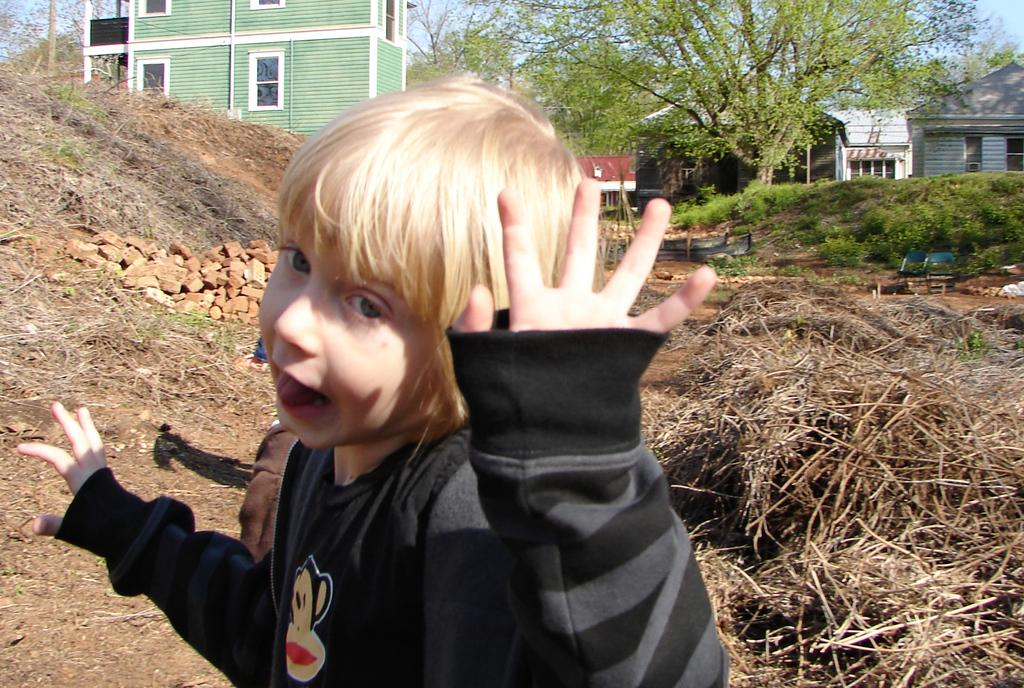What is the main subject of the image? There is a child in the image. What is the child wearing? The child is wearing a black dress. What is the child's posture in the image? The child is standing. What type of vegetation can be seen in the image? Dry grass and trees are present in the image. What type of structures are visible in the image? Bricks and wooden houses are visible in the image. What can be seen in the background of the image? The sky is visible in the background of the image. What type of pleasure can be seen on the horse's face in the image? There is no horse present in the image, so it is not possible to determine the pleasure on its face. 